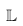<formula> <loc_0><loc_0><loc_500><loc_500>\mathbb { L }</formula> 